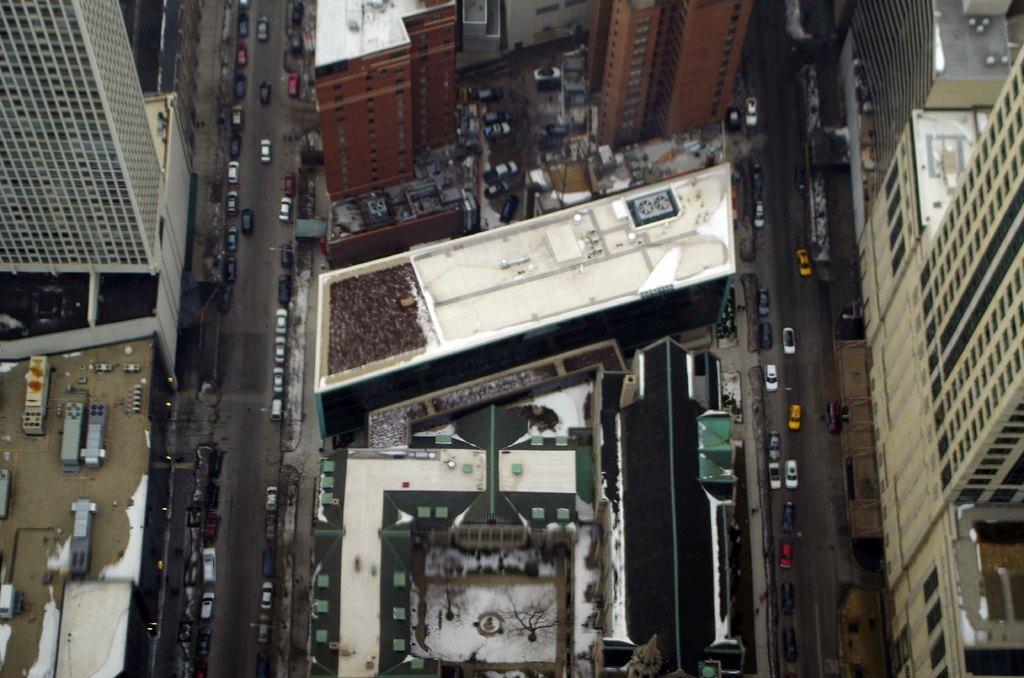Please provide a concise description of this image. In this image, we can see some buildings and vehicles. We can see the ground and some trees. 